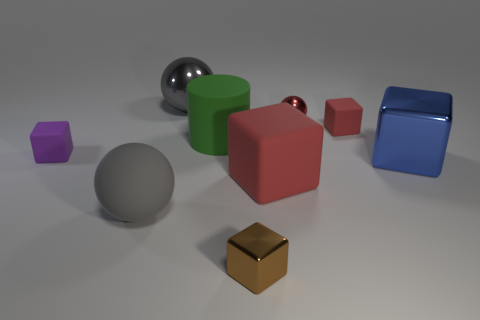Subtract 2 blocks. How many blocks are left? 3 Subtract all small brown blocks. How many blocks are left? 4 Subtract all purple cubes. How many cubes are left? 4 Subtract all yellow cubes. Subtract all green spheres. How many cubes are left? 5 Subtract all blocks. How many objects are left? 4 Add 8 small purple objects. How many small purple objects exist? 9 Subtract 2 red cubes. How many objects are left? 7 Subtract all tiny green objects. Subtract all big matte cubes. How many objects are left? 8 Add 1 tiny red rubber objects. How many tiny red rubber objects are left? 2 